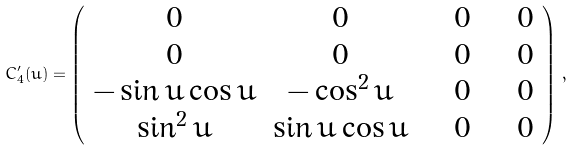Convert formula to latex. <formula><loc_0><loc_0><loc_500><loc_500>\bar { C } _ { 4 } ^ { \prime } ( u ) = \left ( \begin{array} { c c c c } 0 & 0 & \quad 0 & \quad 0 \\ 0 & 0 & \quad 0 & \quad 0 \\ - \sin u \cos u & - \cos ^ { 2 } u & \quad 0 & \quad 0 \\ \sin ^ { 2 } u & \sin u \cos u & \quad 0 & \quad 0 \end{array} \right ) \, ,</formula> 